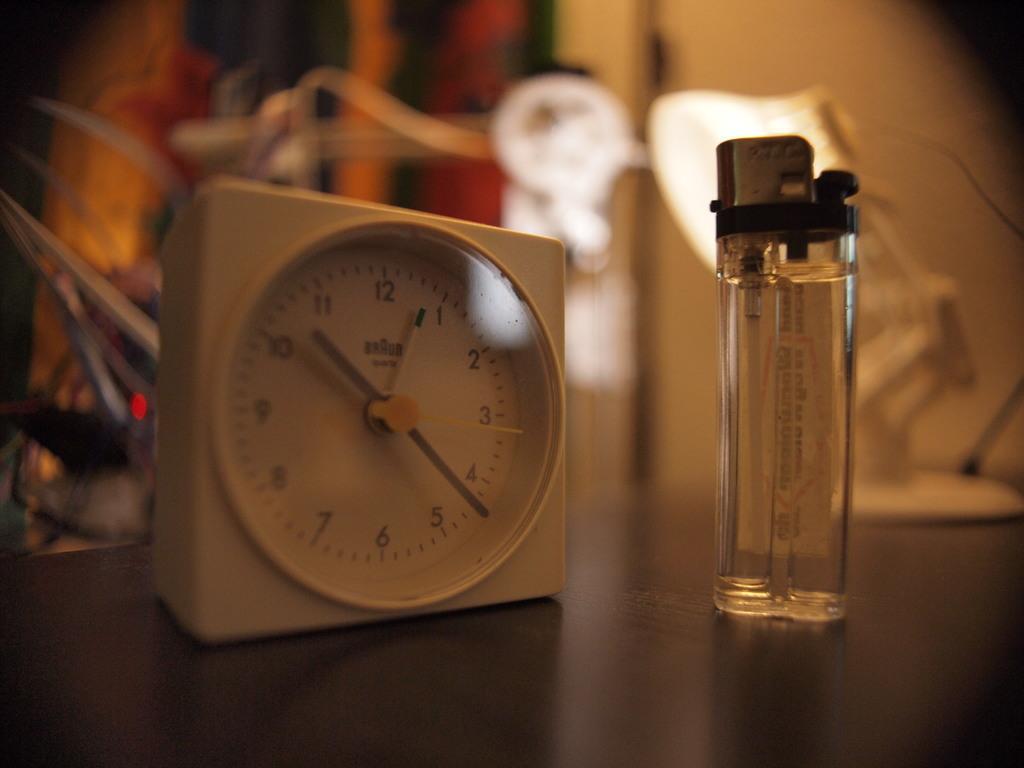Is it after 10:00 on this clock?
Offer a terse response. Yes. What is the exact time on the clock?
Give a very brief answer. 10:23. What time is it?
Your response must be concise. 10:22. What is the hour?
Make the answer very short. 10. 